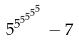<formula> <loc_0><loc_0><loc_500><loc_500>5 ^ { 5 ^ { 5 ^ { 5 ^ { 5 ^ { 5 } } } } } - 7</formula> 